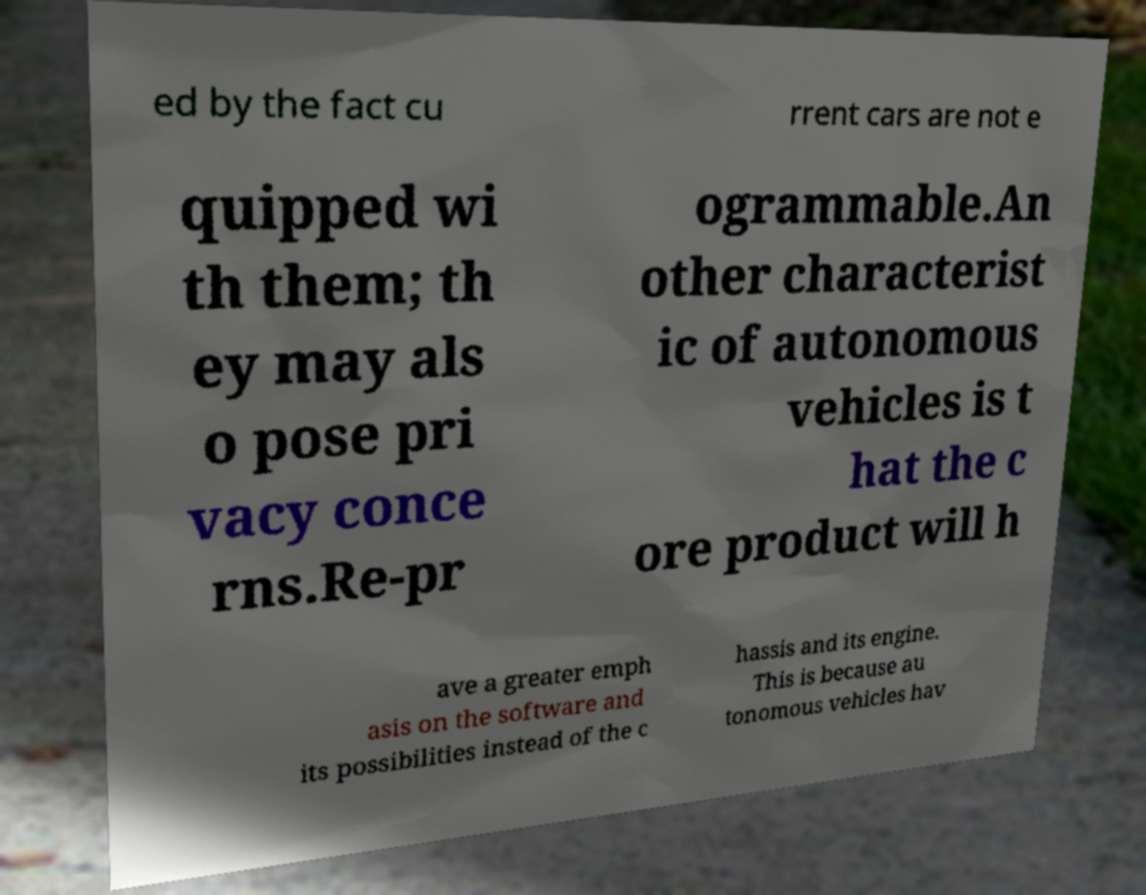Please read and relay the text visible in this image. What does it say? ed by the fact cu rrent cars are not e quipped wi th them; th ey may als o pose pri vacy conce rns.Re-pr ogrammable.An other characterist ic of autonomous vehicles is t hat the c ore product will h ave a greater emph asis on the software and its possibilities instead of the c hassis and its engine. This is because au tonomous vehicles hav 